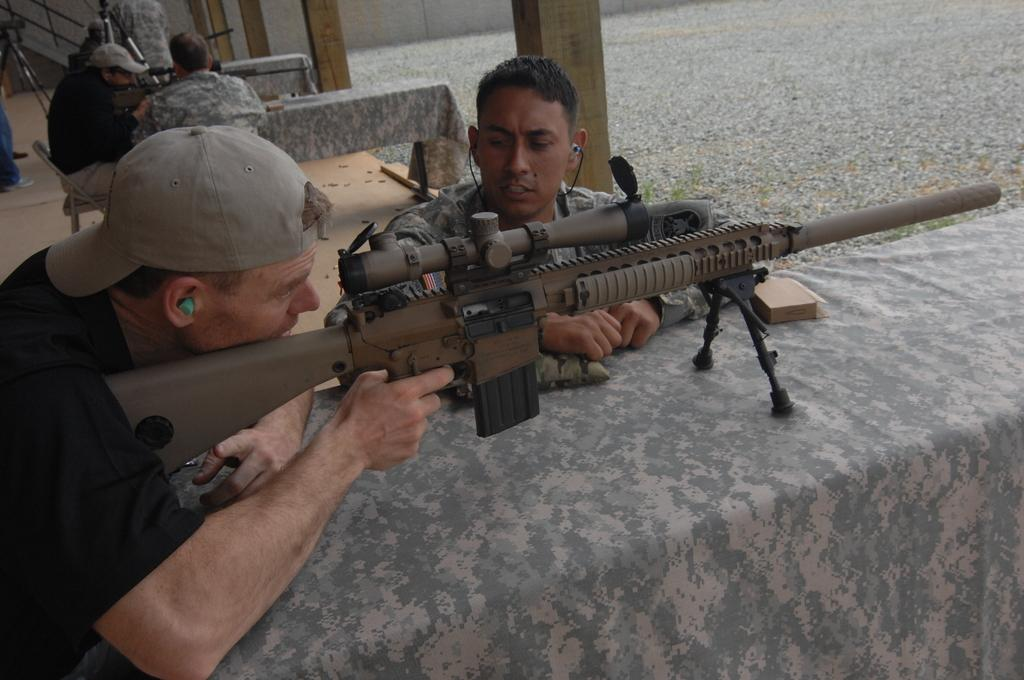How many people are in the group in the image? There is a group of people in the image, but the exact number is not specified. What are some people in the group wearing? Some people in the group are wearing caps. What are some people in the group holding? Some people in the group are holding guns. What type of land can be seen in the background of the image? There is no information about the background or any land in the image. Is there an umbrella visible in the image? No, there is no umbrella present in the image. 